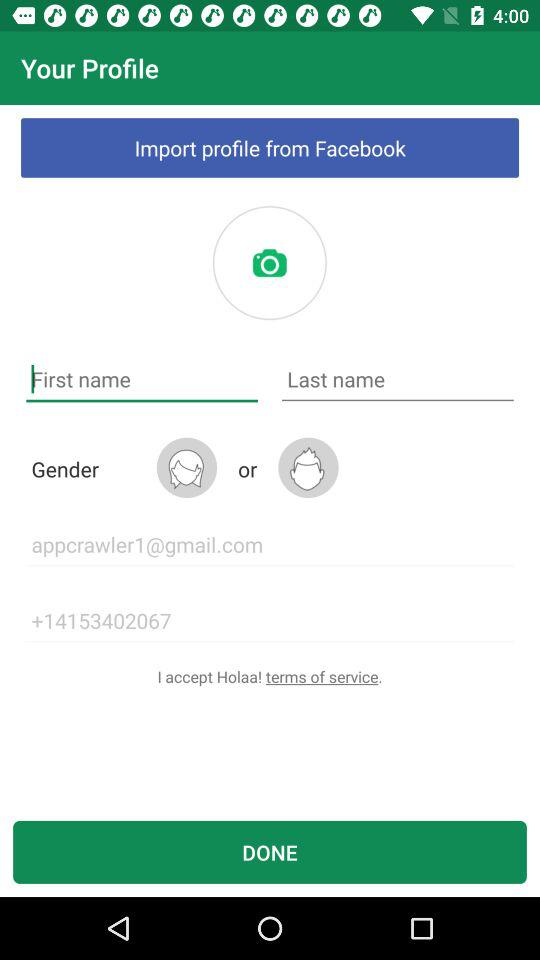What is the contact number? The contact number is +14153402067. 